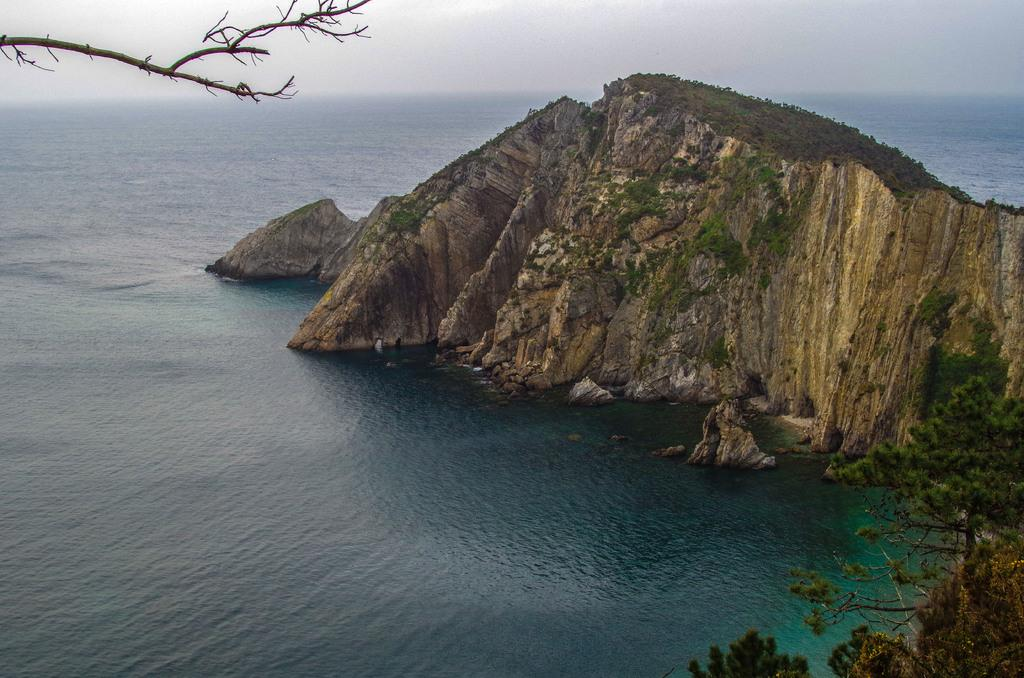What is the main subject in the image? There is a rock in the image. What type of vegetation is present at the bottom of the image? There are trees at the bottom of the image. What can be seen in the background of the image? Water and the sky are visible in the background of the image. Can you describe the argument taking place between the hands in the image? There are no hands or argument present in the image; it features a rock, trees, water, and the sky. 